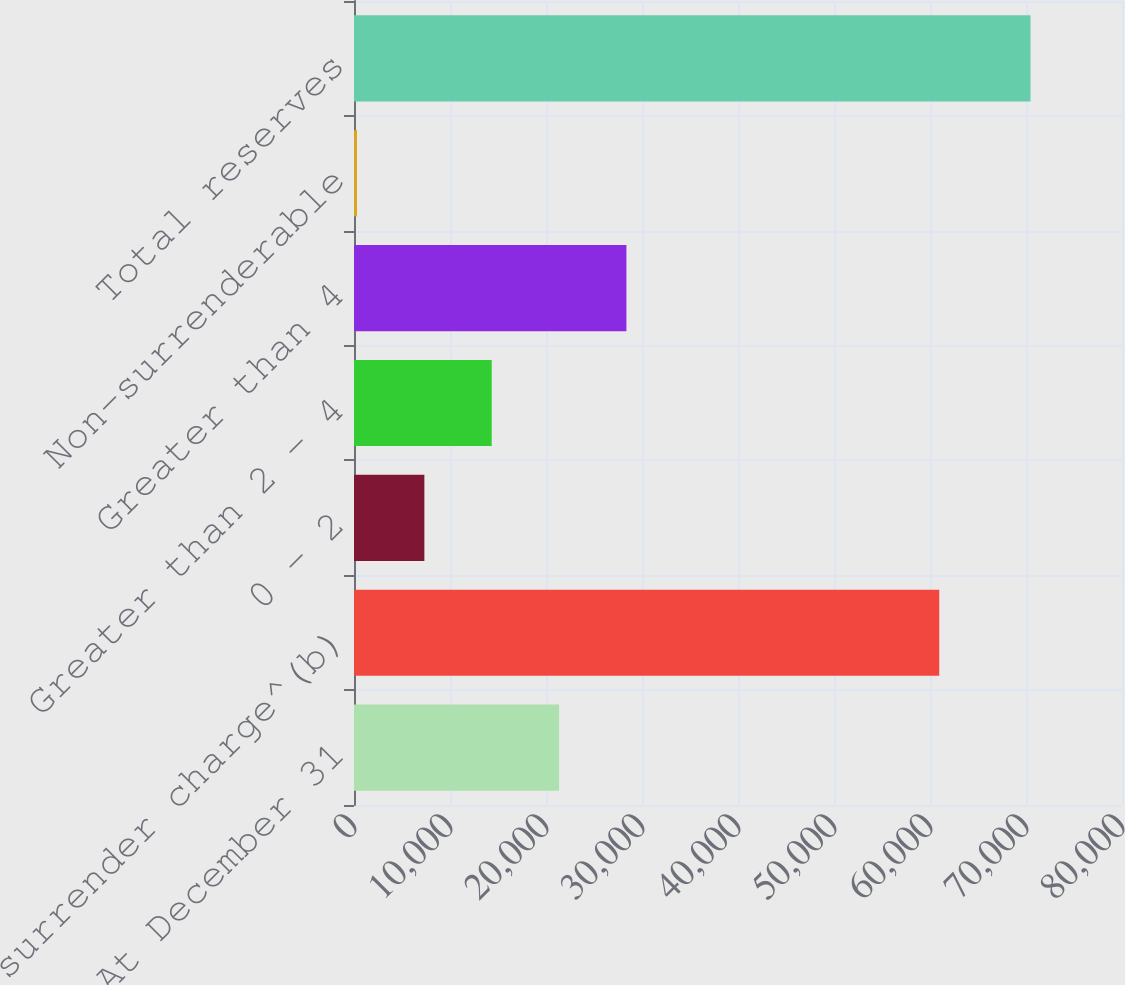Convert chart to OTSL. <chart><loc_0><loc_0><loc_500><loc_500><bar_chart><fcel>At December 31<fcel>No surrender charge^(b)<fcel>0 - 2<fcel>Greater than 2 - 4<fcel>Greater than 4<fcel>Non-surrenderable<fcel>Total reserves<nl><fcel>21361.8<fcel>60962<fcel>7330.6<fcel>14346.2<fcel>28377.4<fcel>315<fcel>70471<nl></chart> 